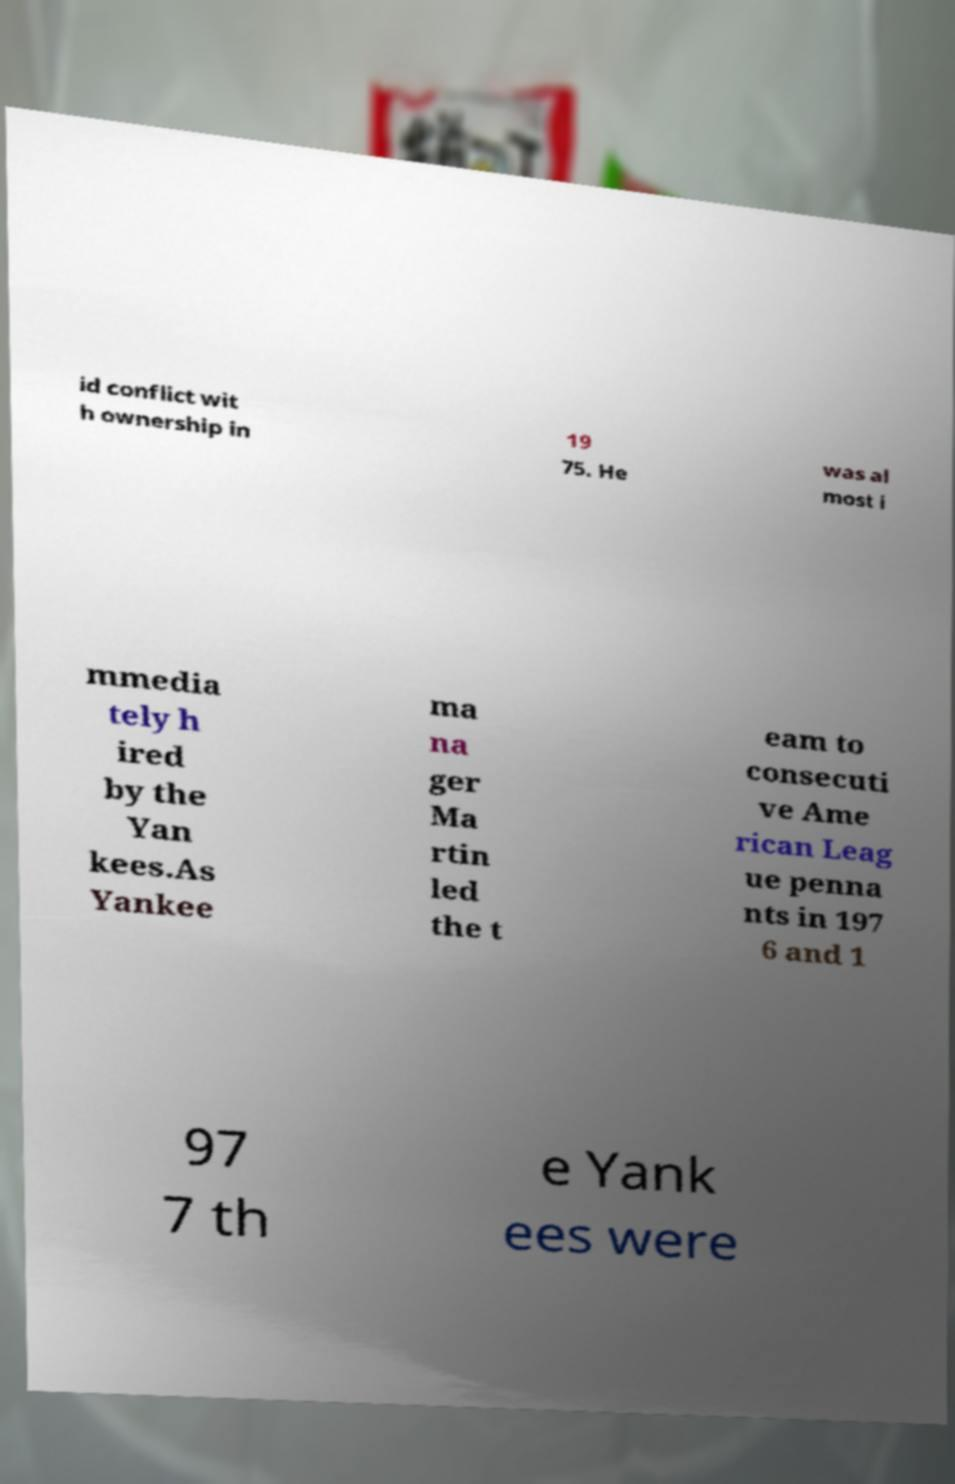Can you accurately transcribe the text from the provided image for me? id conflict wit h ownership in 19 75. He was al most i mmedia tely h ired by the Yan kees.As Yankee ma na ger Ma rtin led the t eam to consecuti ve Ame rican Leag ue penna nts in 197 6 and 1 97 7 th e Yank ees were 